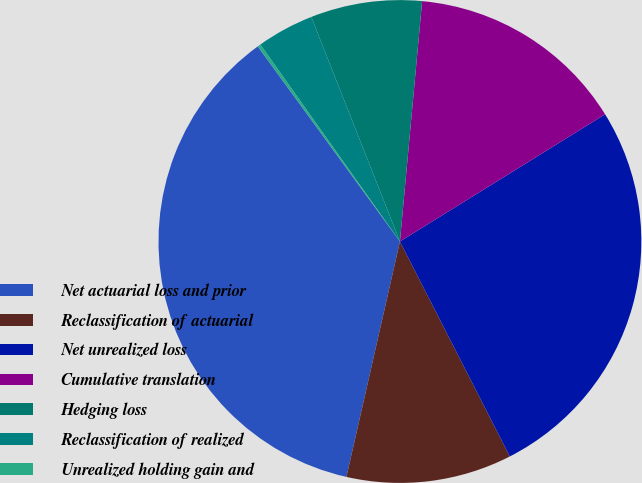Convert chart. <chart><loc_0><loc_0><loc_500><loc_500><pie_chart><fcel>Net actuarial loss and prior<fcel>Reclassification of actuarial<fcel>Net unrealized loss<fcel>Cumulative translation<fcel>Hedging loss<fcel>Reclassification of realized<fcel>Unrealized holding gain and<nl><fcel>36.42%<fcel>11.08%<fcel>26.31%<fcel>14.7%<fcel>7.45%<fcel>3.83%<fcel>0.21%<nl></chart> 